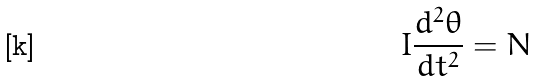<formula> <loc_0><loc_0><loc_500><loc_500>I \frac { d ^ { 2 } \theta } { d t ^ { 2 } } = N</formula> 